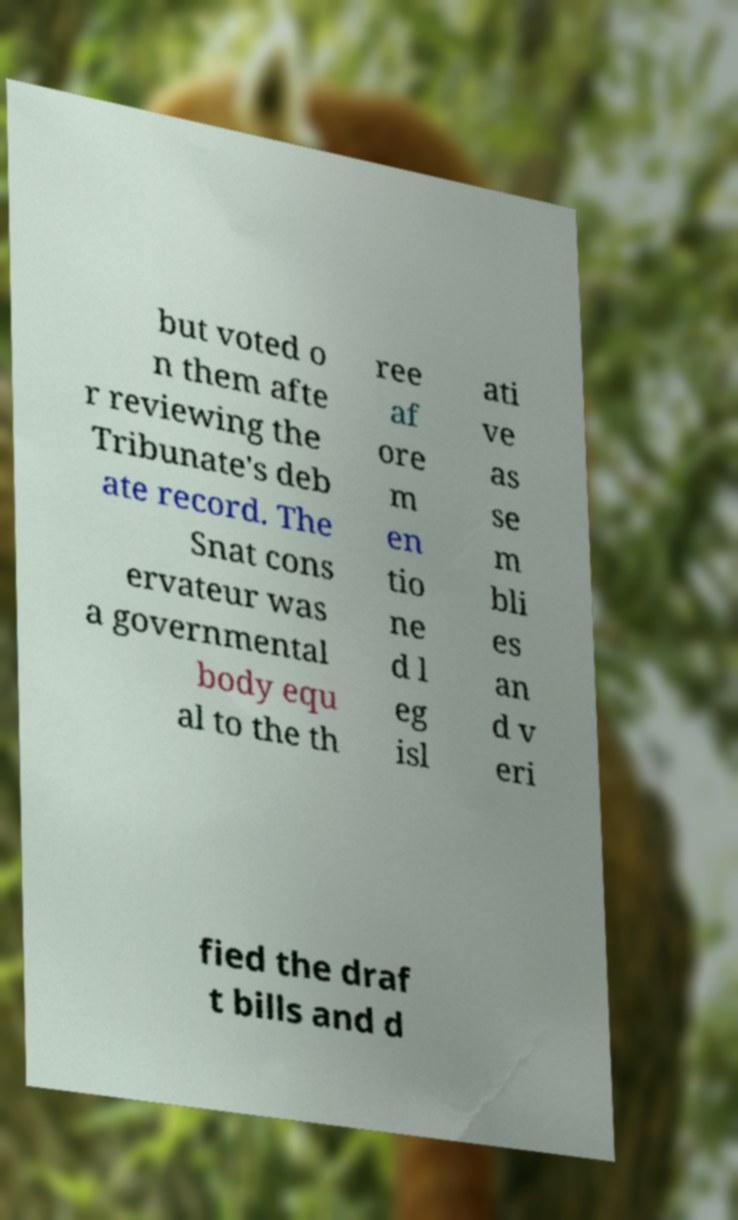What messages or text are displayed in this image? I need them in a readable, typed format. but voted o n them afte r reviewing the Tribunate's deb ate record. The Snat cons ervateur was a governmental body equ al to the th ree af ore m en tio ne d l eg isl ati ve as se m bli es an d v eri fied the draf t bills and d 